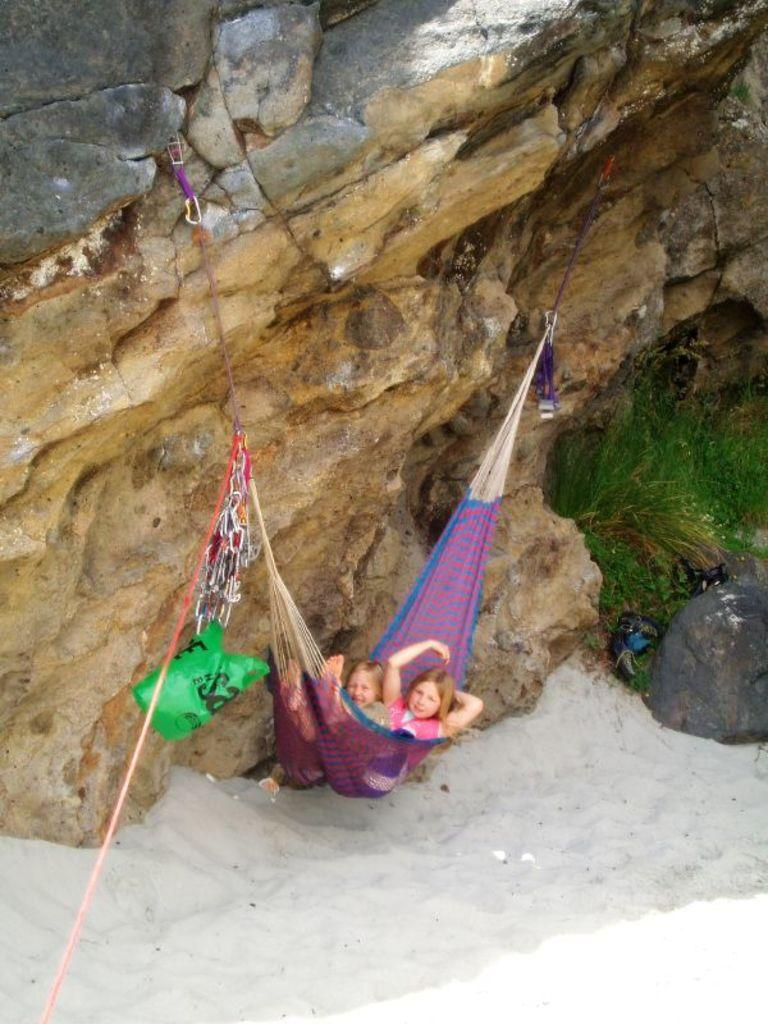What are the two persons doing in the image? The two persons are lying on a hammock. How is the hammock supported in the image? The hammock is tied to a rock. What type of surface is visible at the bottom of the image? There is sand at the bottom of the image. What type of vegetation is on the right side of the image? There is grass on the right side of the image. What type of linen is being used by the porter in the image? There is no porter present in the image, and therefore no linen being used. What sound can be heard coming from the whistle in the image? There is no whistle present in the image, so no sound can be heard. 